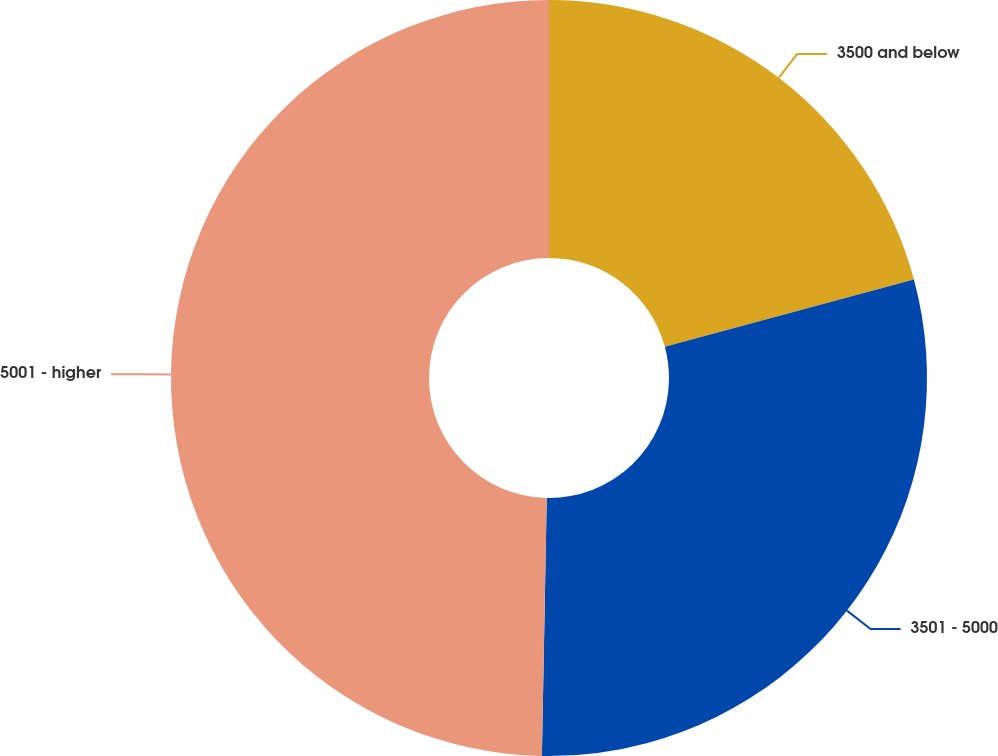<chart> <loc_0><loc_0><loc_500><loc_500><pie_chart><fcel>3500 and below<fcel>3501 - 5000<fcel>5001 - higher<nl><fcel>20.8%<fcel>29.5%<fcel>49.7%<nl></chart> 